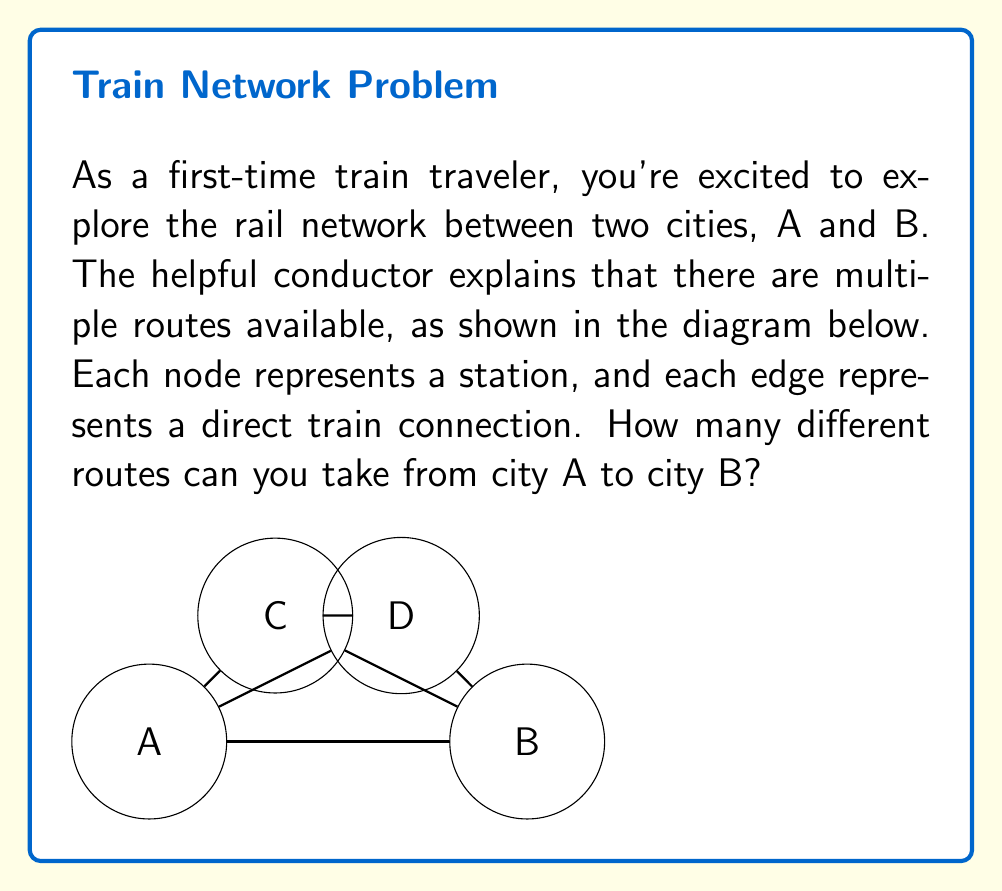Could you help me with this problem? Let's approach this step-by-step:

1) First, we need to identify all possible paths from A to B:
   - A → B (direct)
   - A → C → B
   - A → D → B
   - A → C → D → B
   - A → D → C → B

2) To count these paths, we can use the addition principle of combinatorics. We'll sum the number of paths for each possible route length:

   $$ \text{Total paths} = \text{1-segment paths} + \text{2-segment paths} + \text{3-segment paths} $$

3) Let's count each type:
   - 1-segment paths: There is only one (A → B)
   - 2-segment paths: There are two (A → C → B and A → D → B)
   - 3-segment paths: There are two (A → C → D → B and A → D → C → B)

4) Now we can sum these up:

   $$ \text{Total paths} = 1 + 2 + 2 = 5 $$

Thus, there are 5 different routes you can take from city A to city B.
Answer: 5 